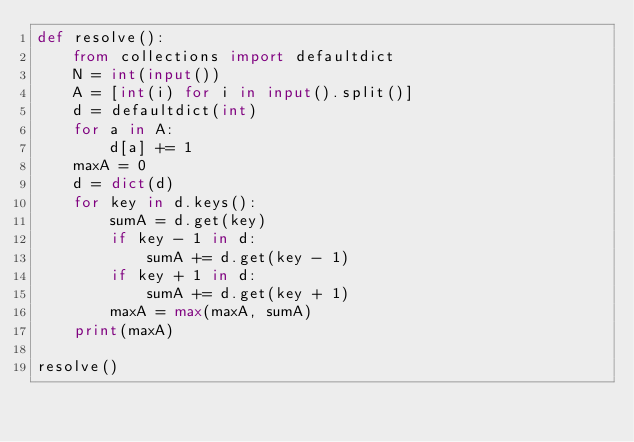<code> <loc_0><loc_0><loc_500><loc_500><_Python_>def resolve():
    from collections import defaultdict
    N = int(input())
    A = [int(i) for i in input().split()]
    d = defaultdict(int)
    for a in A:
        d[a] += 1
    maxA = 0
    d = dict(d)
    for key in d.keys():
        sumA = d.get(key)
        if key - 1 in d:
            sumA += d.get(key - 1)
        if key + 1 in d:
            sumA += d.get(key + 1)
        maxA = max(maxA, sumA)
    print(maxA)

resolve()
</code> 